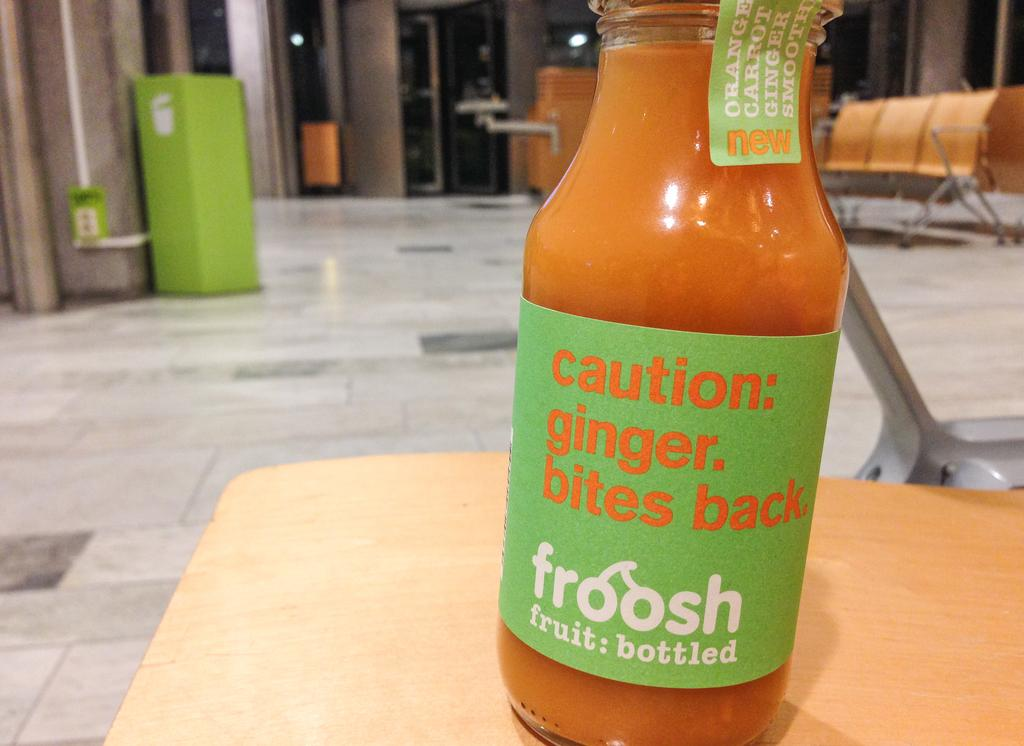<image>
Summarize the visual content of the image. A bottle from Froosh with a warning about ginger bites back. 